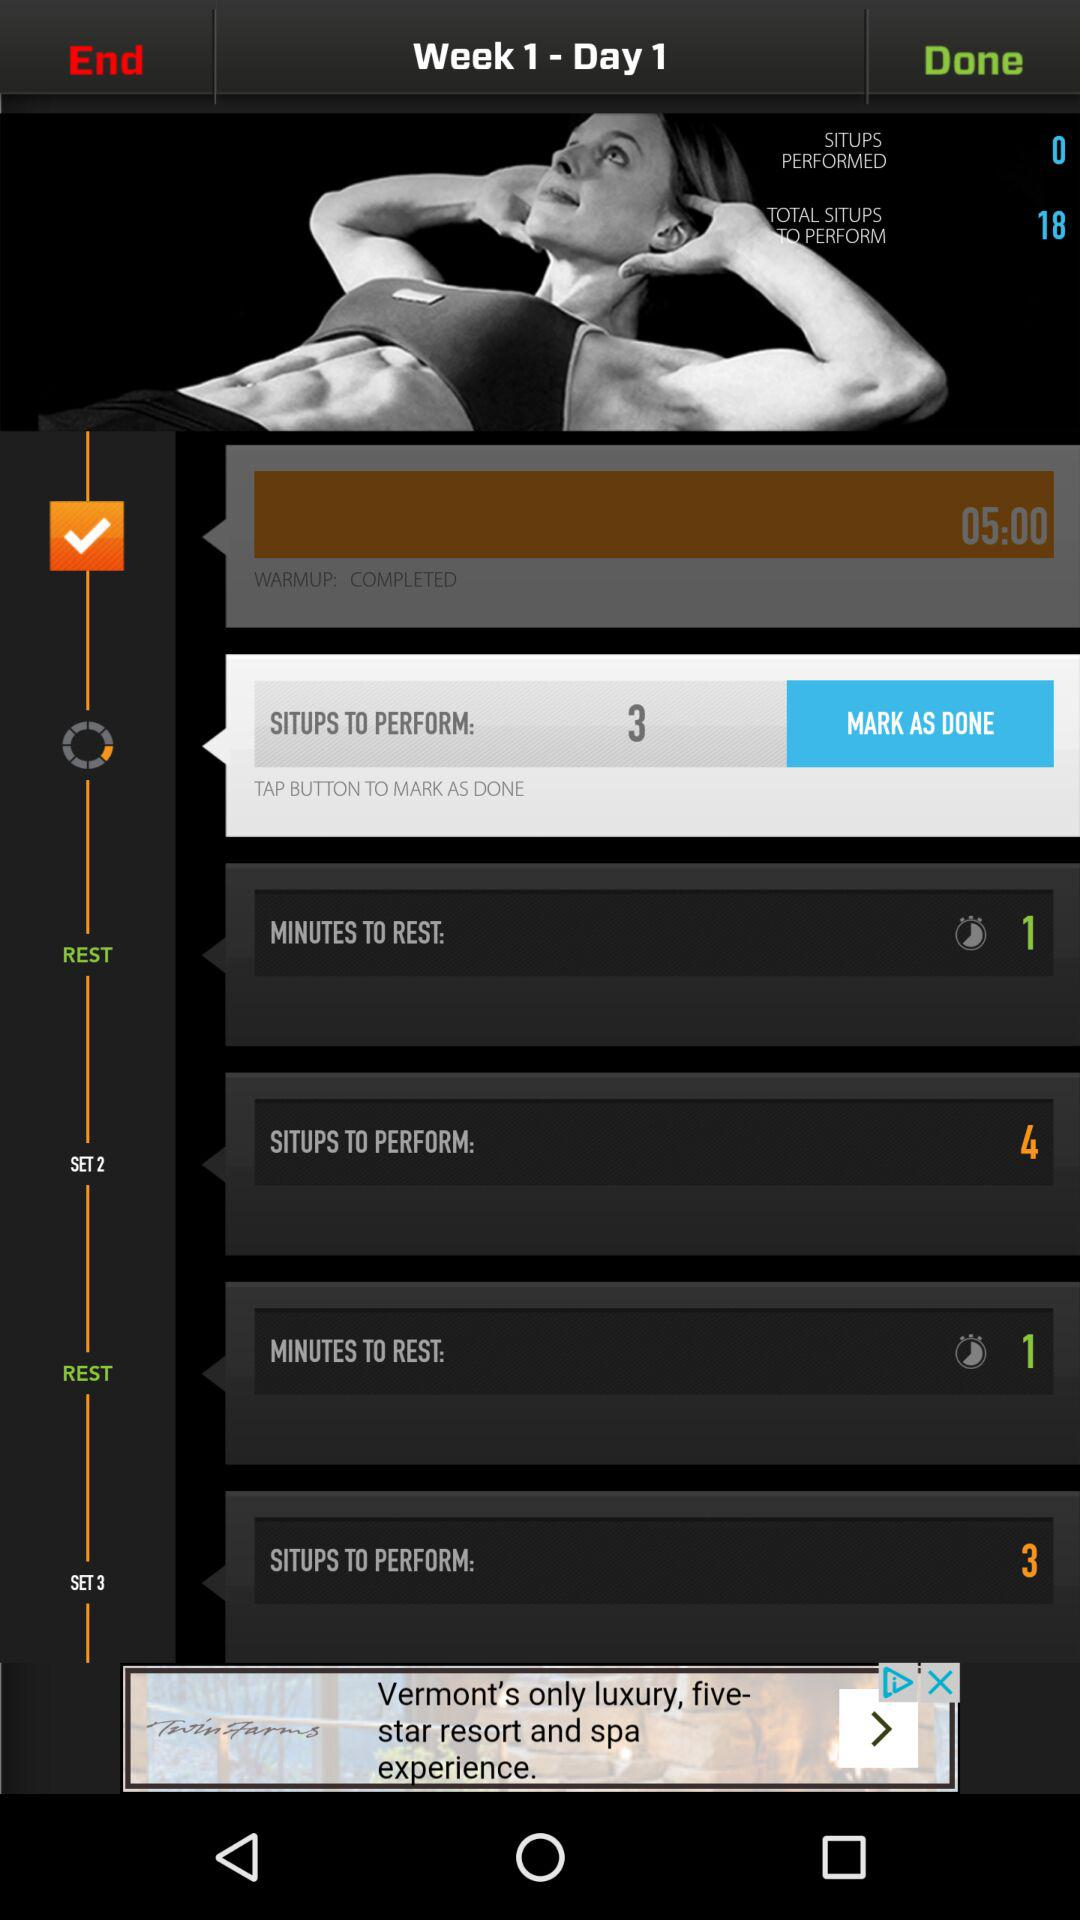What is the name of the application?
When the provided information is insufficient, respond with <no answer>. <no answer> 